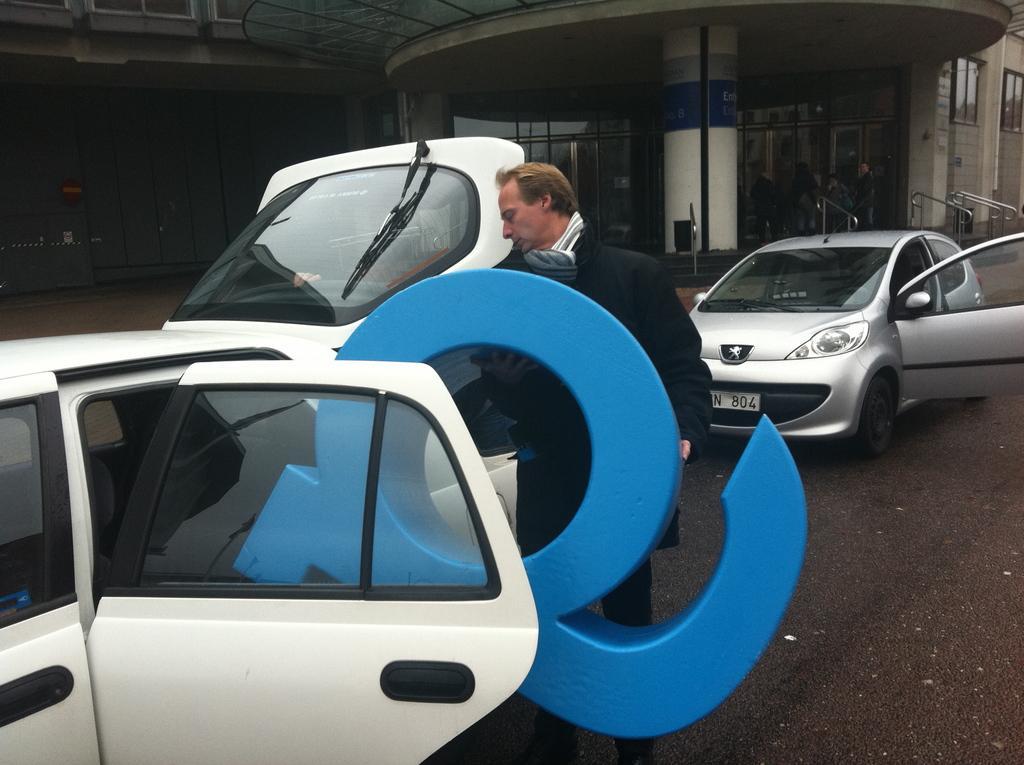Describe this image in one or two sentences. In this picture I can see the road in front and I can see 2 cars, where I can see a man standing in front and holding a blue color thing. In the background I can see a building and I can see few people. 